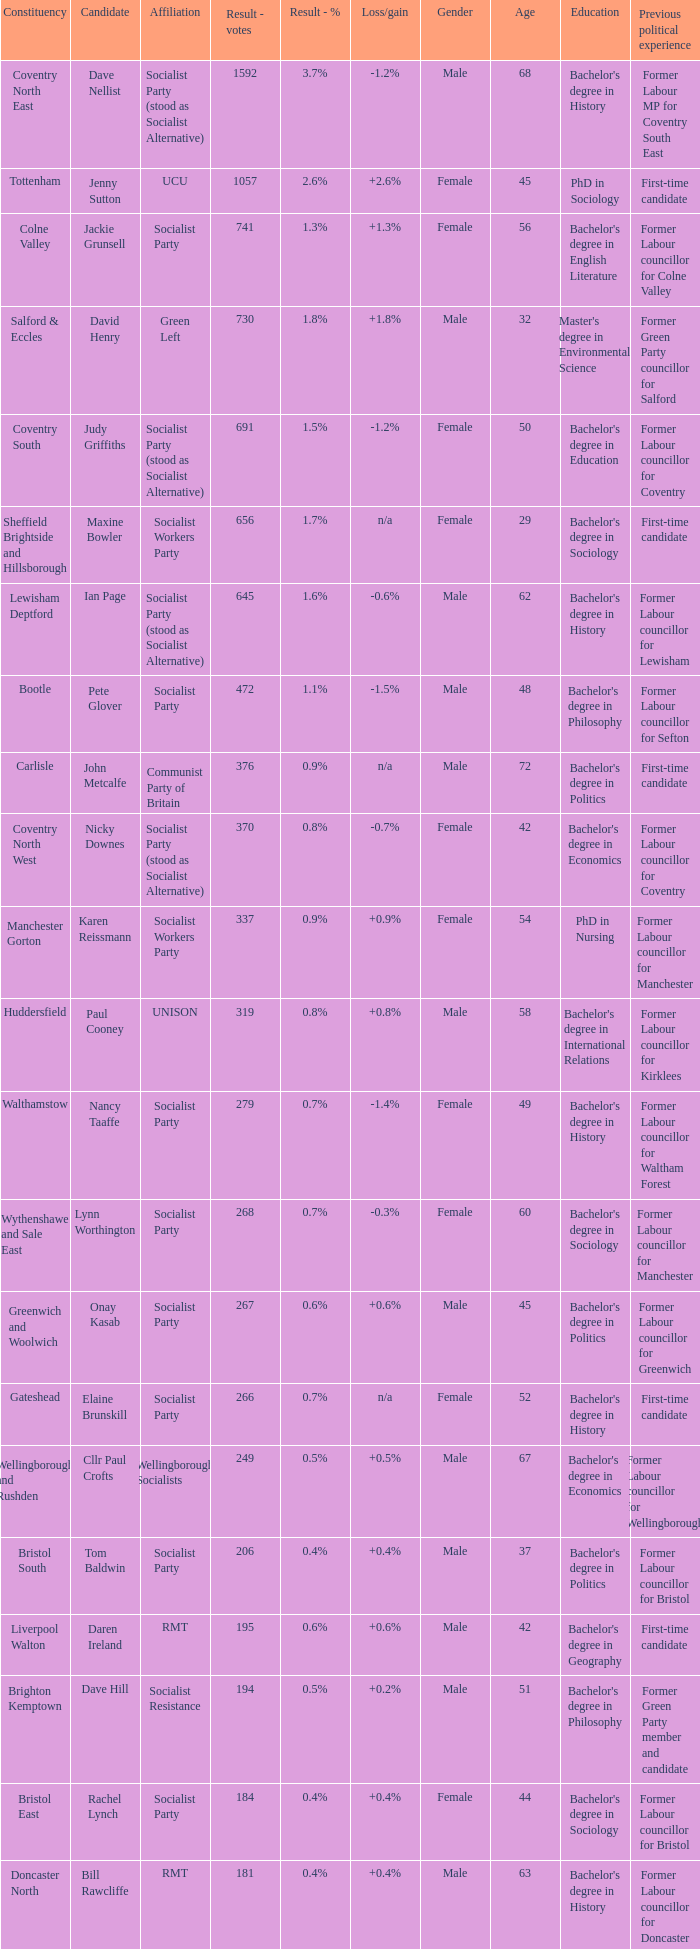What is the largest vote result for the Huddersfield constituency? 319.0. 